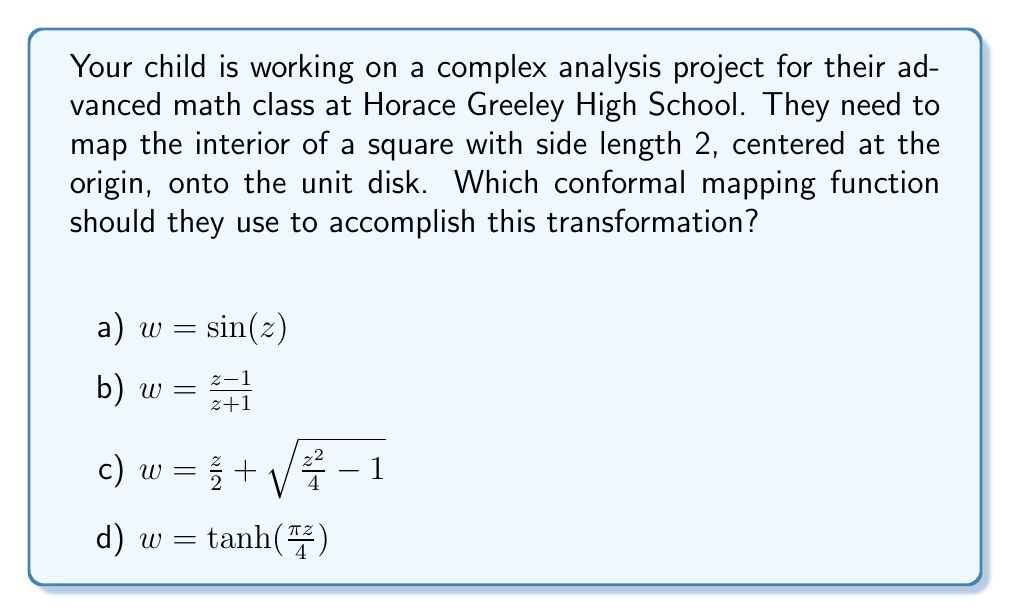Show me your answer to this math problem. To solve this problem, we need to consider the properties of conformal mappings and the specific regions we're working with:

1) The square is centered at the origin with side length 2, so its vertices are at $(\pm 1, \pm 1)$ in the complex plane.

2) We need to map this square onto the unit disk, which is defined as $|w| \leq 1$ in the complex plane.

3) Let's examine each option:

   a) $w = \sin(z)$ is a periodic function and doesn't map the square to a disk.
   
   b) $w = \frac{z - 1}{z + 1}$ is the Möbius transformation that maps the right half-plane to the unit disk, not our square.
   
   c) $w = \frac{z}{2} + \sqrt{\frac{z^2}{4} - 1}$ is the Joukowski transformation, used for airfoil analysis, not for square-to-disk mapping.
   
   d) $w = \tanh(\frac{\pi z}{4})$ is the correct choice.

4) The hyperbolic tangent function has the following properties:
   - It maps the infinite strip $-1 \leq \text{Re}(z) \leq 1$ to the unit disk.
   - The factor $\frac{\pi}{4}$ scales the square to fit this strip.

5) We can verify this mapping:
   - When $z = \pm 1 \pm i$, $|\tanh(\frac{\pi z}{4})| = 1$, mapping the vertices of the square to the boundary of the unit disk.
   - The origin $(0,0)$ maps to itself.
   - The real axis $[-1,1]$ maps to $[-\tanh(\frac{\pi}{4}),\tanh(\frac{\pi}{4})]$ on the real axis of the $w$-plane.
   - The imaginary axis $[-i,i]$ maps to $[-i\tan(\frac{\pi}{4}),i\tan(\frac{\pi}{4})]$ on the imaginary axis of the $w$-plane.

Therefore, $w = \tanh(\frac{\pi z}{4})$ is the correct conformal mapping to transform the given square to the unit disk.
Answer: d) $w = \tanh(\frac{\pi z}{4})$ 